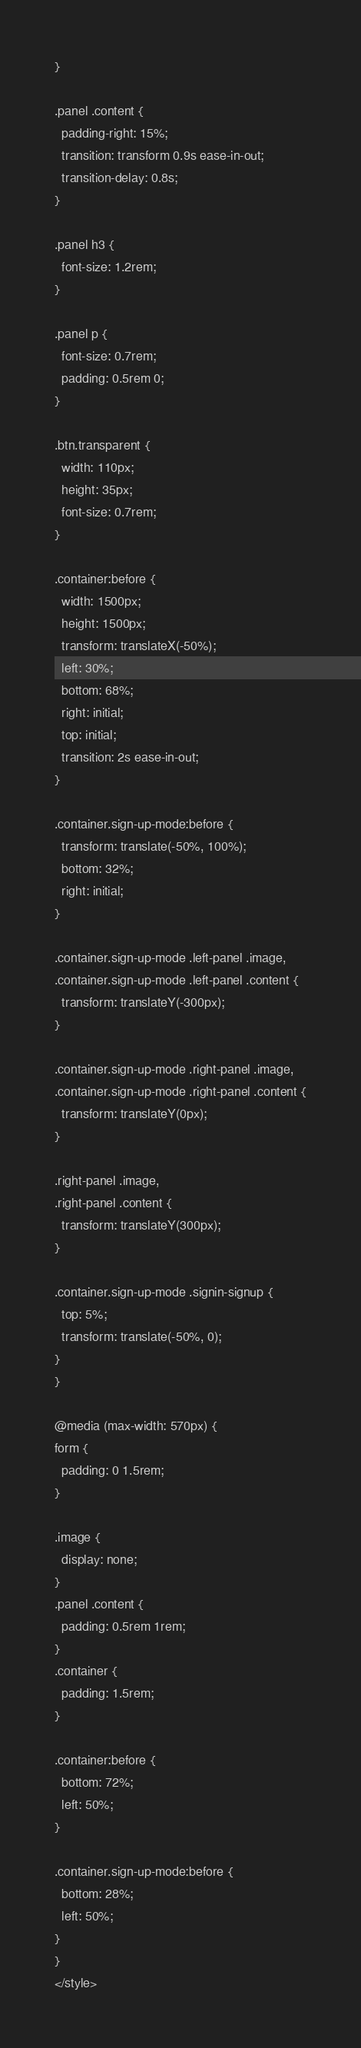Convert code to text. <code><loc_0><loc_0><loc_500><loc_500><_PHP_>}

.panel .content {
  padding-right: 15%;
  transition: transform 0.9s ease-in-out;
  transition-delay: 0.8s;
}

.panel h3 {
  font-size: 1.2rem;
}

.panel p {
  font-size: 0.7rem;
  padding: 0.5rem 0;
}

.btn.transparent {
  width: 110px;
  height: 35px;
  font-size: 0.7rem;
}

.container:before {
  width: 1500px;
  height: 1500px;
  transform: translateX(-50%);
  left: 30%;
  bottom: 68%;
  right: initial;
  top: initial;
  transition: 2s ease-in-out;
}

.container.sign-up-mode:before {
  transform: translate(-50%, 100%);
  bottom: 32%;
  right: initial;
}

.container.sign-up-mode .left-panel .image,
.container.sign-up-mode .left-panel .content {
  transform: translateY(-300px);
}

.container.sign-up-mode .right-panel .image,
.container.sign-up-mode .right-panel .content {
  transform: translateY(0px);
}

.right-panel .image,
.right-panel .content {
  transform: translateY(300px);
}

.container.sign-up-mode .signin-signup {
  top: 5%;
  transform: translate(-50%, 0);
}
}

@media (max-width: 570px) {
form {
  padding: 0 1.5rem;
}

.image {
  display: none;
}
.panel .content {
  padding: 0.5rem 1rem;
}
.container {
  padding: 1.5rem;
}

.container:before {
  bottom: 72%;
  left: 50%;
}

.container.sign-up-mode:before {
  bottom: 28%;
  left: 50%;
}
}
</style>
</code> 